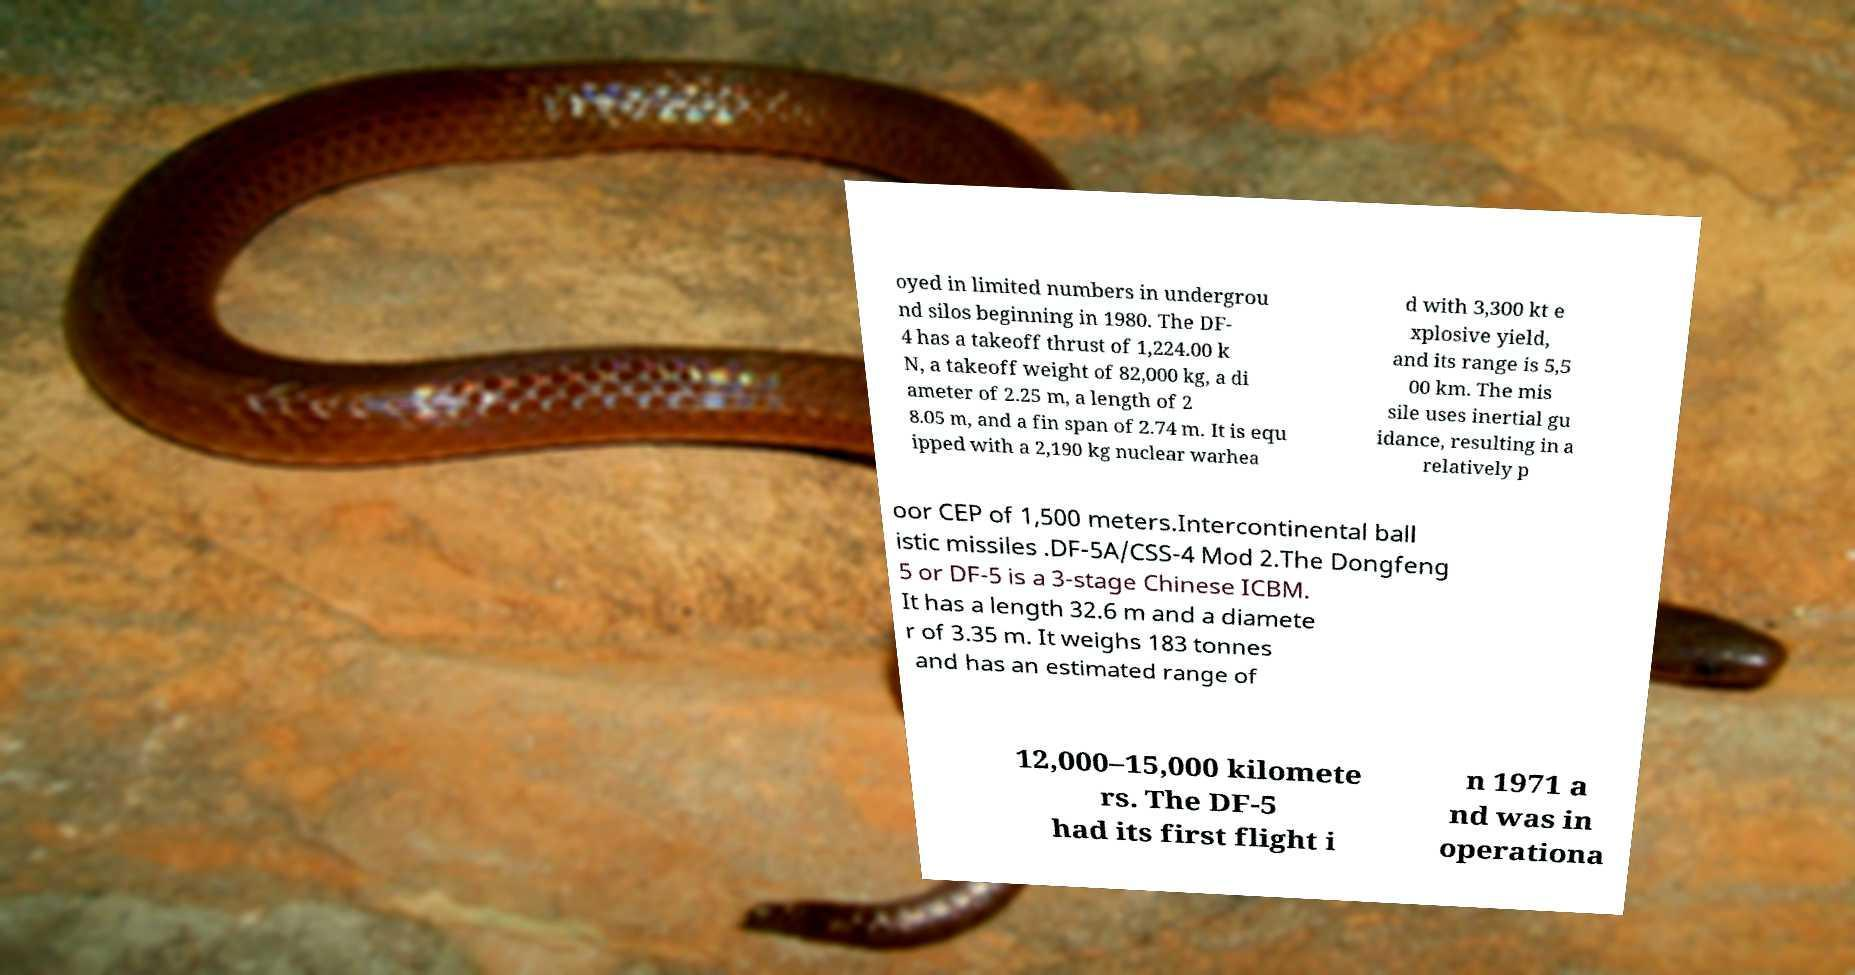Could you extract and type out the text from this image? oyed in limited numbers in undergrou nd silos beginning in 1980. The DF- 4 has a takeoff thrust of 1,224.00 k N, a takeoff weight of 82,000 kg, a di ameter of 2.25 m, a length of 2 8.05 m, and a fin span of 2.74 m. It is equ ipped with a 2,190 kg nuclear warhea d with 3,300 kt e xplosive yield, and its range is 5,5 00 km. The mis sile uses inertial gu idance, resulting in a relatively p oor CEP of 1,500 meters.Intercontinental ball istic missiles .DF-5A/CSS-4 Mod 2.The Dongfeng 5 or DF-5 is a 3-stage Chinese ICBM. It has a length 32.6 m and a diamete r of 3.35 m. It weighs 183 tonnes and has an estimated range of 12,000–15,000 kilomete rs. The DF-5 had its first flight i n 1971 a nd was in operationa 